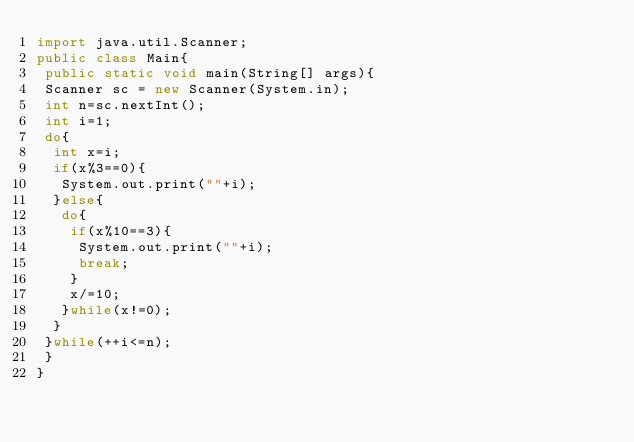<code> <loc_0><loc_0><loc_500><loc_500><_Java_>import java.util.Scanner;
public class Main{
 public static void main(String[] args){
 Scanner sc = new Scanner(System.in);
 int n=sc.nextInt();
 int i=1;
 do{
  int x=i;
  if(x%3==0){
   System.out.print(""+i);
  }else{
   do{
    if(x%10==3){
     System.out.print(""+i);
     break;
    }
    x/=10;
   }while(x!=0);
  }
 }while(++i<=n);
 }
}</code> 